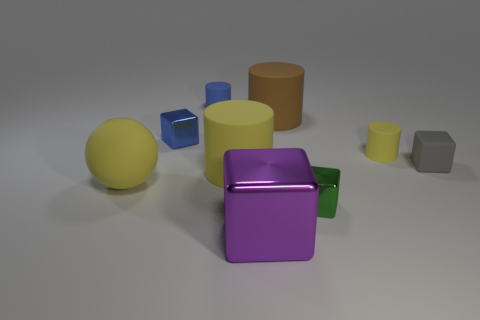Subtract all gray blocks. How many blocks are left? 3 Add 1 metallic objects. How many objects exist? 10 Subtract all purple cubes. How many cubes are left? 3 Add 7 blue objects. How many blue objects exist? 9 Subtract 1 blue blocks. How many objects are left? 8 Subtract all cylinders. How many objects are left? 5 Subtract all green balls. Subtract all brown blocks. How many balls are left? 1 Subtract all brown cylinders. How many purple cubes are left? 1 Subtract all cyan cylinders. Subtract all brown matte things. How many objects are left? 8 Add 6 metal objects. How many metal objects are left? 9 